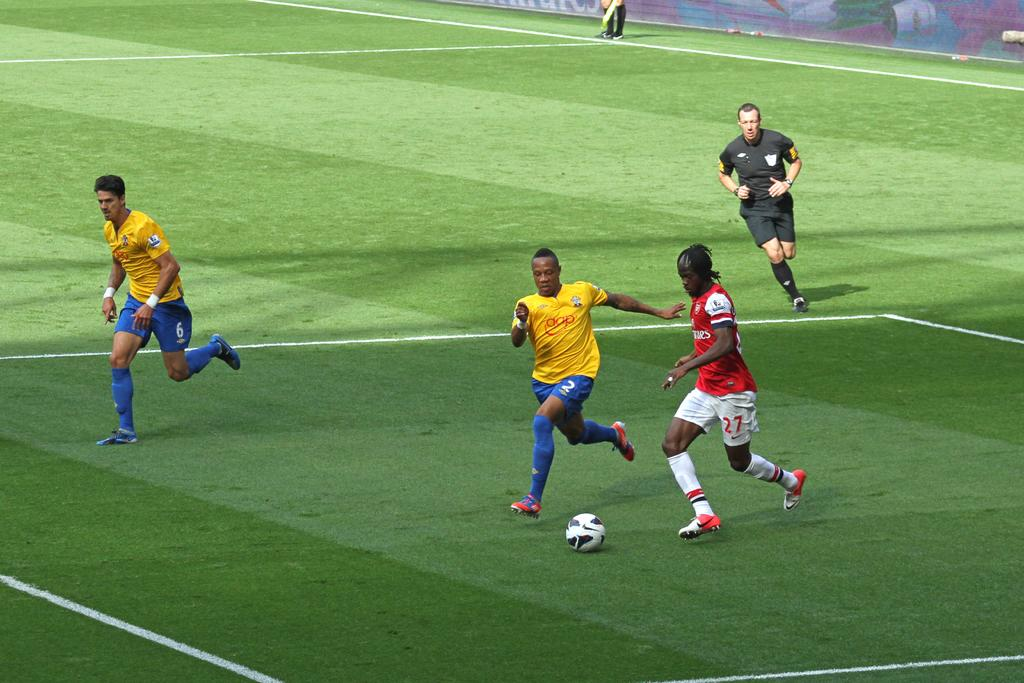What type of field is shown in the image? There is a football ground in the image. What distinguishing features can be seen on the football ground? There are white lines on the football ground. How many people are present on the football ground? There are five persons standing on the football ground. What object is visible on the football ground? There is a white-colored football visible in the image. Can you see any goldfish swimming in the image? There are no goldfish present in the image; it features a football ground with a football and five persons. 